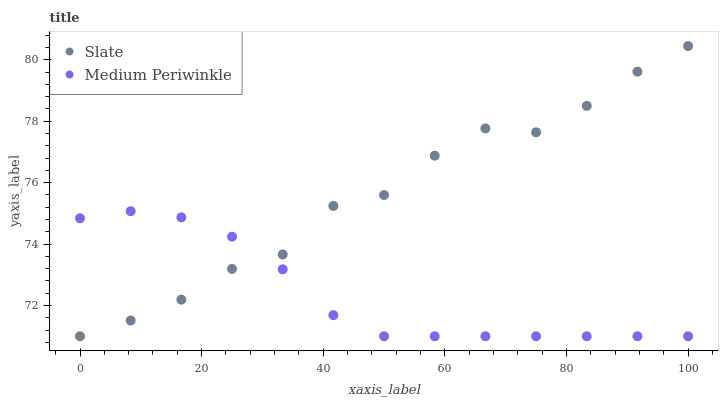Does Medium Periwinkle have the minimum area under the curve?
Answer yes or no. Yes. Does Slate have the maximum area under the curve?
Answer yes or no. Yes. Does Medium Periwinkle have the maximum area under the curve?
Answer yes or no. No. Is Medium Periwinkle the smoothest?
Answer yes or no. Yes. Is Slate the roughest?
Answer yes or no. Yes. Is Medium Periwinkle the roughest?
Answer yes or no. No. Does Slate have the lowest value?
Answer yes or no. Yes. Does Slate have the highest value?
Answer yes or no. Yes. Does Medium Periwinkle have the highest value?
Answer yes or no. No. Does Slate intersect Medium Periwinkle?
Answer yes or no. Yes. Is Slate less than Medium Periwinkle?
Answer yes or no. No. Is Slate greater than Medium Periwinkle?
Answer yes or no. No. 